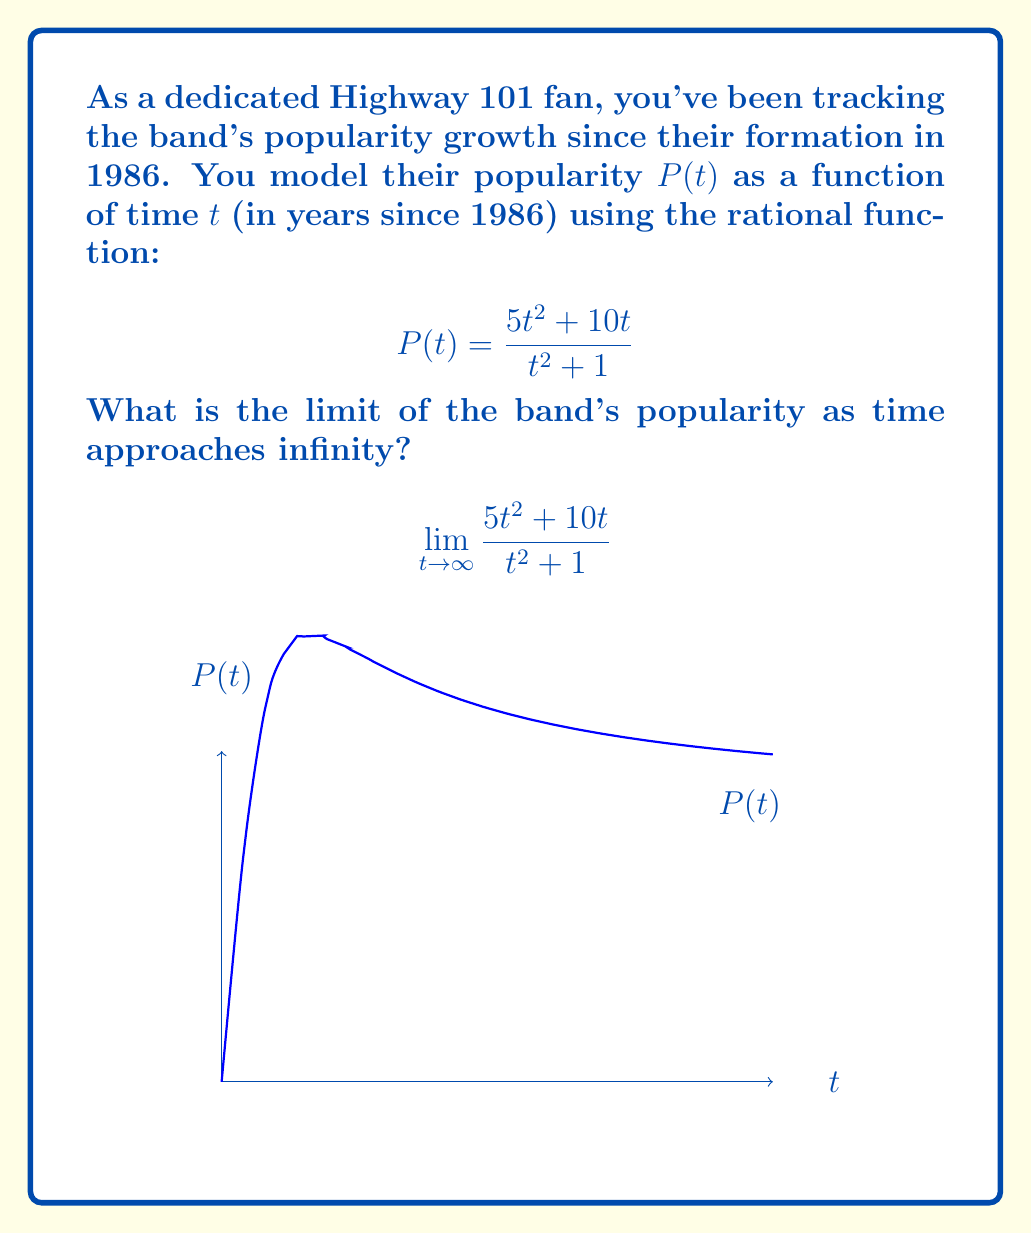Provide a solution to this math problem. To find the limit as $t$ approaches infinity, we'll follow these steps:

1) First, divide both the numerator and denominator by the highest power of $t$ in the denominator, which is $t^2$:

   $$\lim_{t \to \infty} \frac{5t^2 + 10t}{t^2 + 1} = \lim_{t \to \infty} \frac{\frac{5t^2}{t^2} + \frac{10t}{t^2}}{\frac{t^2}{t^2} + \frac{1}{t^2}}$$

2) Simplify:

   $$\lim_{t \to \infty} \frac{5 + \frac{10}{t}}{1 + \frac{1}{t^2}}$$

3) As $t$ approaches infinity, $\frac{1}{t}$ and $\frac{1}{t^2}$ approach 0:

   $$\lim_{t \to \infty} \frac{5 + 0}{1 + 0} = \frac{5}{1} = 5$$

Therefore, the limit of the band's popularity as time approaches infinity is 5.
Answer: 5 